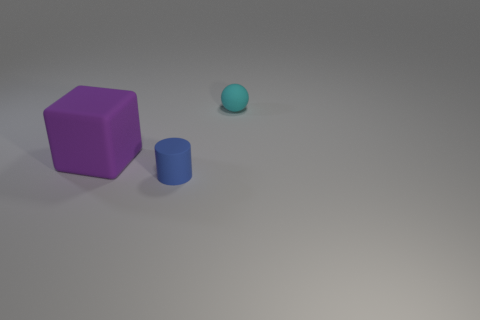Is there any other thing that has the same shape as the blue rubber object?
Your response must be concise. No. Are there the same number of matte balls that are behind the cyan thing and blue objects?
Provide a short and direct response. No. What number of things are both right of the tiny blue matte object and in front of the cyan sphere?
Ensure brevity in your answer.  0. How many small cylinders are the same material as the cyan sphere?
Keep it short and to the point. 1. Is the number of tiny cyan spheres that are to the left of the big purple rubber object less than the number of big matte blocks?
Offer a terse response. Yes. How many red objects are there?
Make the answer very short. 0. Is the cyan rubber thing the same shape as the blue object?
Keep it short and to the point. No. There is a cyan thing that is right of the large purple rubber block behind the blue object; what size is it?
Your response must be concise. Small. Is there a blue matte thing that has the same size as the cylinder?
Offer a very short reply. No. There is a thing behind the big purple thing; is its size the same as the rubber object that is to the left of the blue matte object?
Keep it short and to the point. No. 